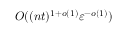Convert formula to latex. <formula><loc_0><loc_0><loc_500><loc_500>O ( ( n t ) ^ { 1 + o ( 1 ) } \varepsilon ^ { - o ( 1 ) } )</formula> 